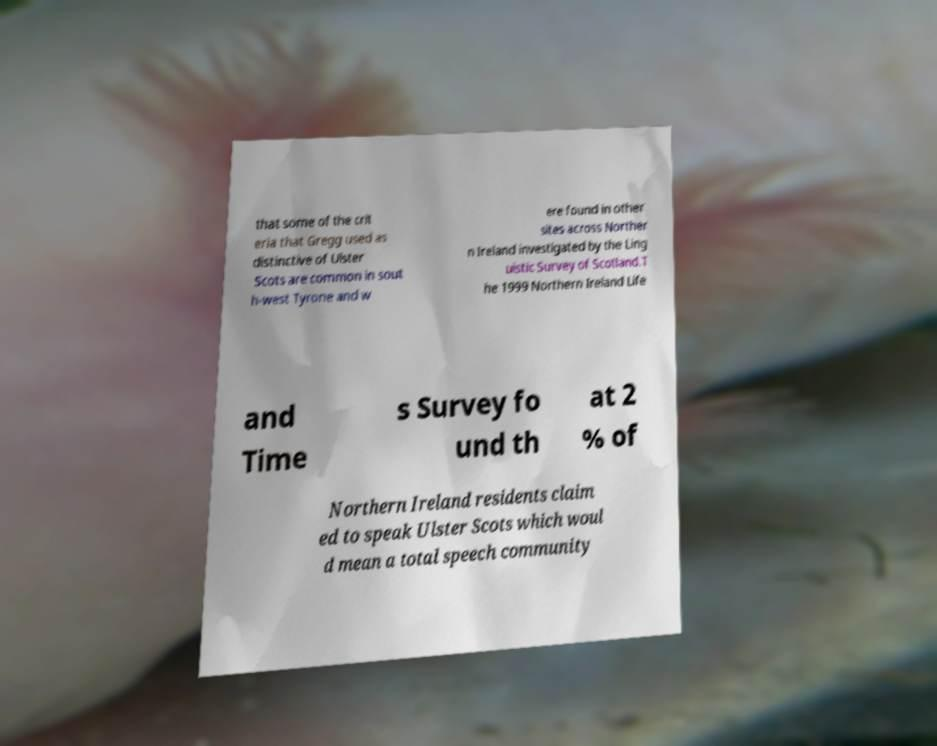What messages or text are displayed in this image? I need them in a readable, typed format. that some of the crit eria that Gregg used as distinctive of Ulster Scots are common in sout h-west Tyrone and w ere found in other sites across Norther n Ireland investigated by the Ling uistic Survey of Scotland.T he 1999 Northern Ireland Life and Time s Survey fo und th at 2 % of Northern Ireland residents claim ed to speak Ulster Scots which woul d mean a total speech community 